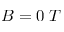<formula> <loc_0><loc_0><loc_500><loc_500>B = 0 \, T</formula> 